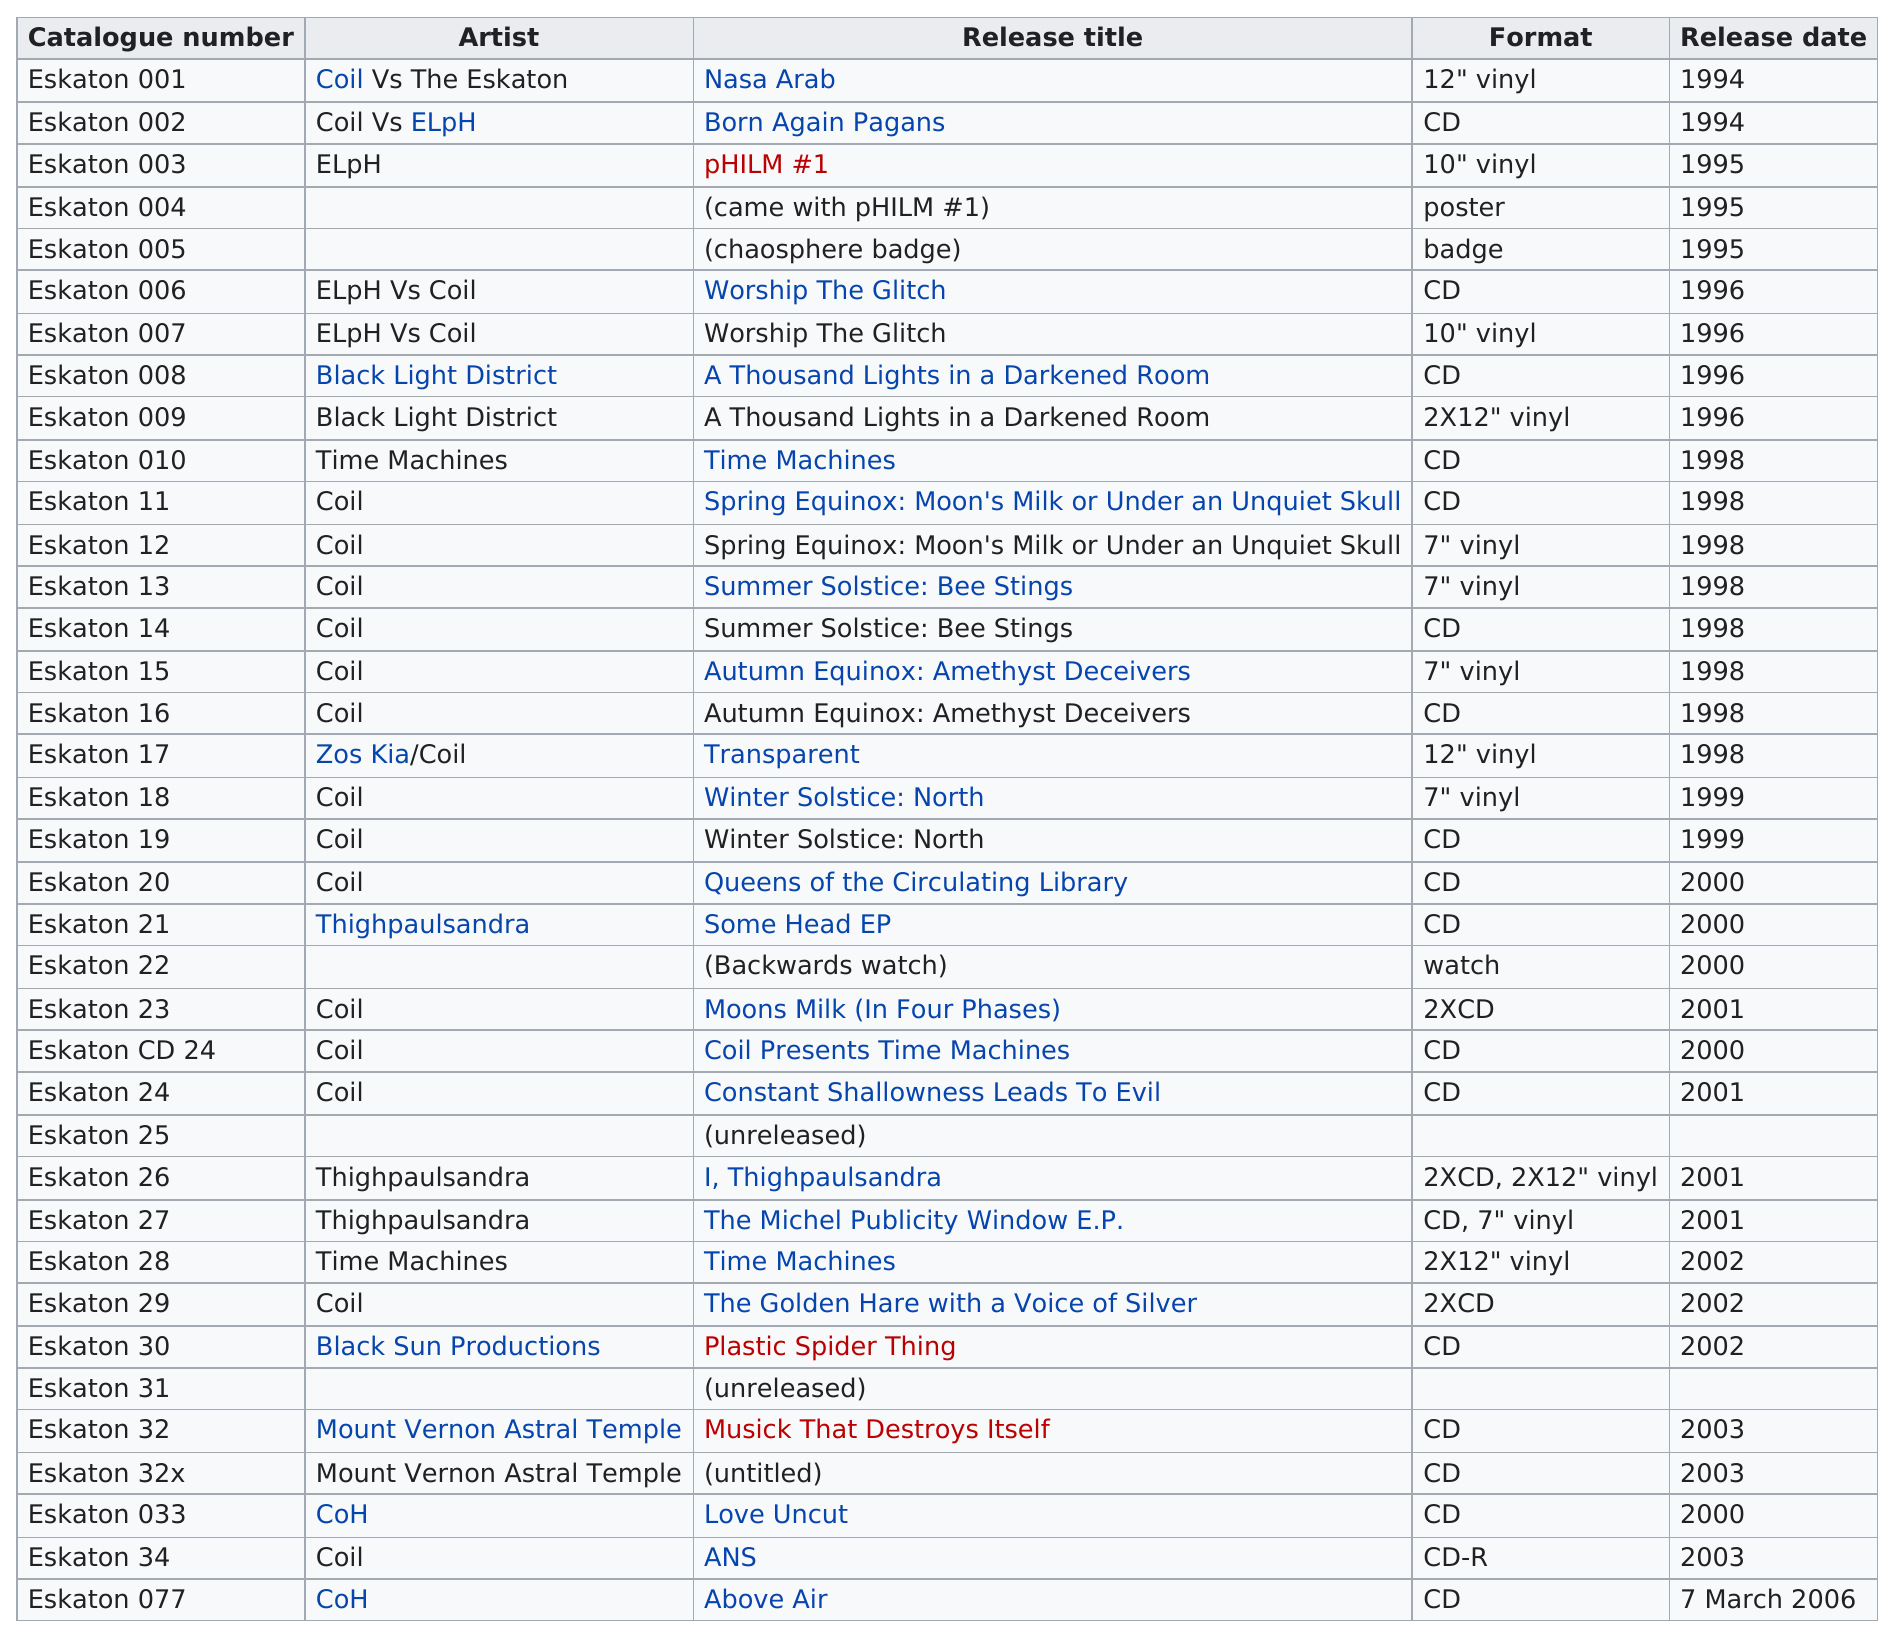Identify some key points in this picture. Coil had more than six release titles. The total number of titles released on 7" vinyl by Coil is currently unknown. The first year that there were no titles released on vinyl was 2000. The sole release by the artist known as Black Sun Productions was entitled 'Plastic Spider Thing'. The first release title of the COH (Children of the Hunger) was "Love Uncut. 